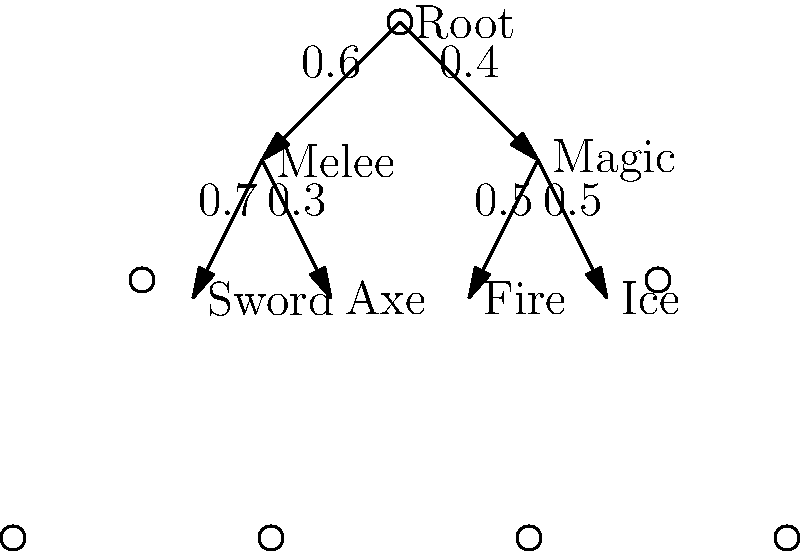In Dungeons of Dredmor, you're allocating skill points using a decision tree. The tree shows probabilities of choosing different skill paths. If you have 100 skill points to distribute, and each end node (Sword, Axe, Fire, Ice) requires an equal number of points, how many points should be allocated to the "Fire" skill to maximize expected value, assuming the effectiveness of each skill is directly proportional to its probability of being chosen? To solve this problem, we'll follow these steps:

1) First, calculate the probability of reaching each end node:
   - P(Sword) = 0.6 * 0.7 = 0.42
   - P(Axe) = 0.6 * 0.3 = 0.18
   - P(Fire) = 0.4 * 0.5 = 0.20
   - P(Ice) = 0.4 * 0.5 = 0.20

2) The total probability is 1, confirming our calculations.

3) Since each end node requires an equal number of points, and there are 4 end nodes, each will get 25 points (100 / 4 = 25).

4) To maximize expected value, we allocate points proportionally to the probability of reaching each node.

5) For the "Fire" skill:
   - Probability of reaching Fire = 0.20
   - Points for Fire = 100 * 0.20 = 20 points

Therefore, to maximize expected value, 20 points should be allocated to the "Fire" skill.
Answer: 20 points 